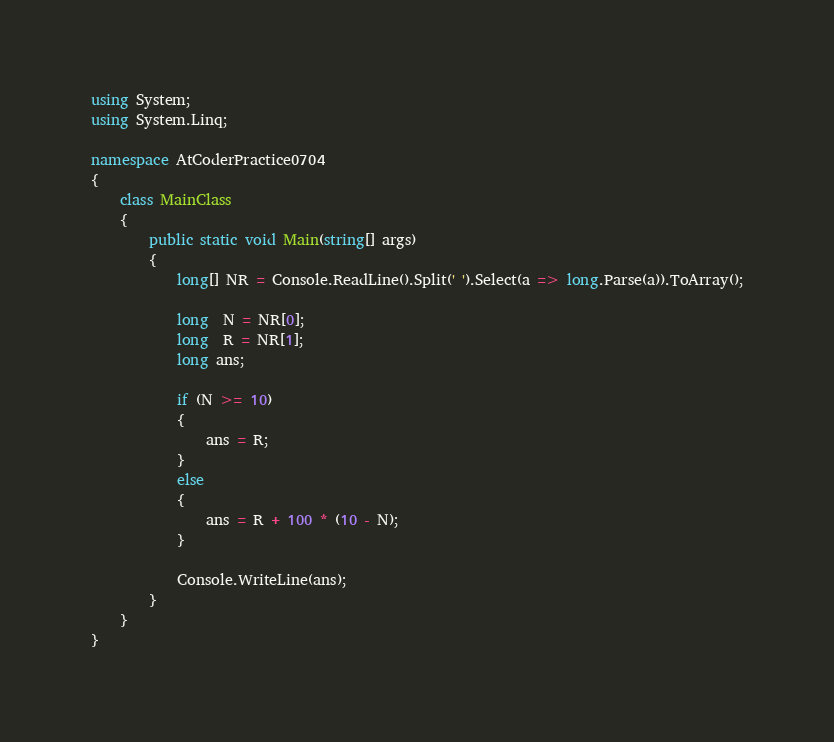<code> <loc_0><loc_0><loc_500><loc_500><_C#_>using System;
using System.Linq;

namespace AtCoderPractice0704
{
    class MainClass
    {
        public static void Main(string[] args)
        {
            long[] NR = Console.ReadLine().Split(' ').Select(a => long.Parse(a)).ToArray();

            long  N = NR[0];
            long  R = NR[1];
            long ans;

            if (N >= 10)
            {
                ans = R;
            }
            else
            {
                ans = R + 100 * (10 - N);
            }

            Console.WriteLine(ans);
        }
    }
}
</code> 